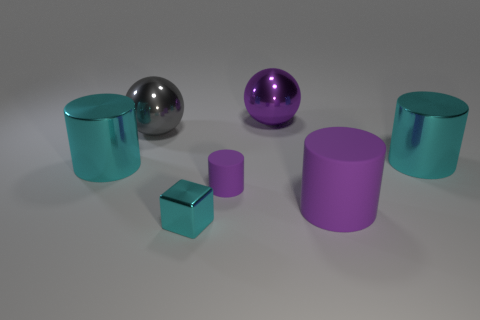There is a big purple metal thing that is behind the cyan shiny object in front of the cyan object that is on the left side of the metal block; what is its shape?
Make the answer very short. Sphere. What material is the large object that is behind the tiny matte cylinder and to the right of the big purple ball?
Make the answer very short. Metal. What number of spheres are the same size as the shiny block?
Offer a terse response. 0. How many rubber things are either large gray balls or tiny cyan blocks?
Ensure brevity in your answer.  0. What material is the cyan cube?
Provide a short and direct response. Metal. There is a small metal thing; how many cyan cubes are to the right of it?
Provide a short and direct response. 0. Do the cyan object that is to the right of the cube and the tiny cylinder have the same material?
Your answer should be compact. No. How many big metal things are the same shape as the small purple thing?
Offer a terse response. 2. What number of tiny objects are either metallic cubes or blue spheres?
Offer a terse response. 1. Does the large rubber cylinder that is in front of the tiny purple object have the same color as the small rubber thing?
Provide a short and direct response. Yes. 